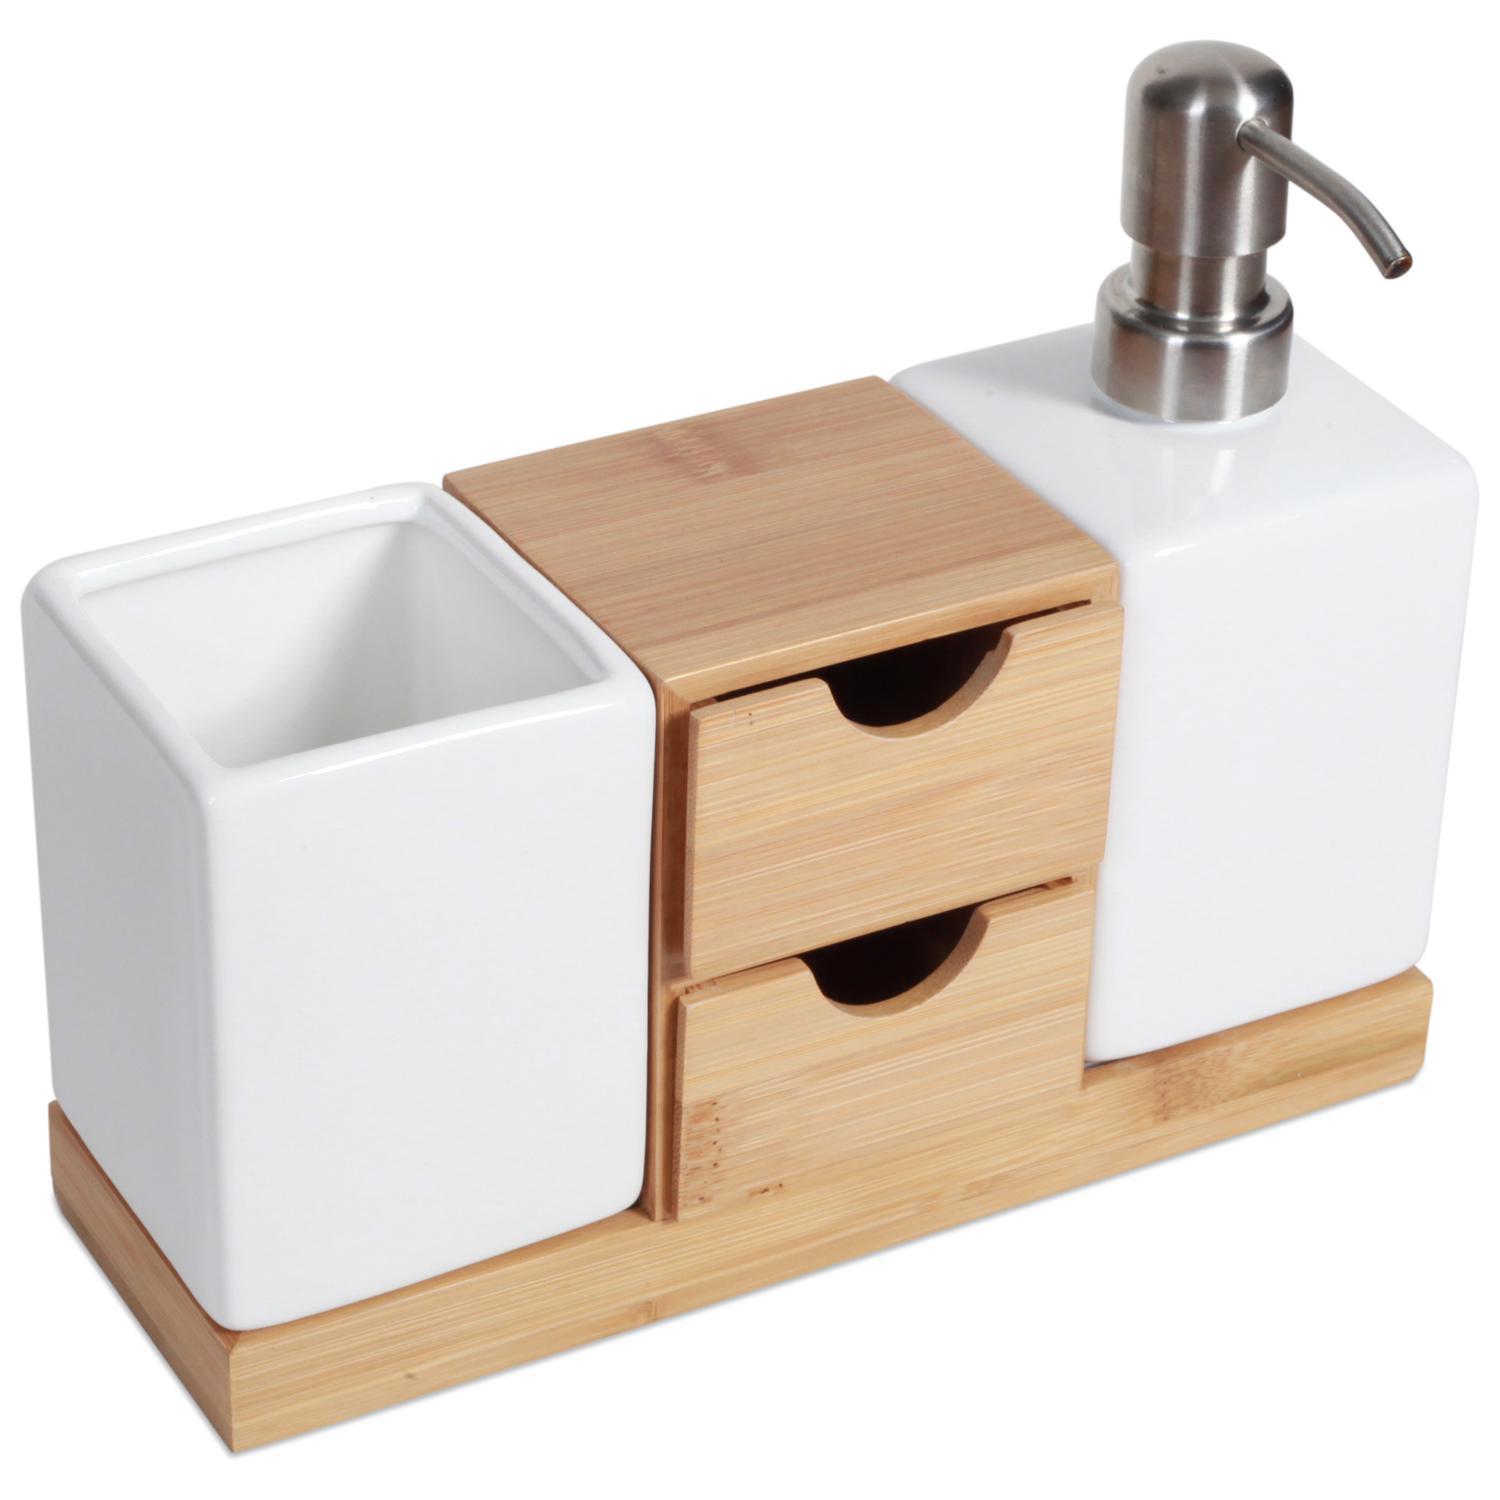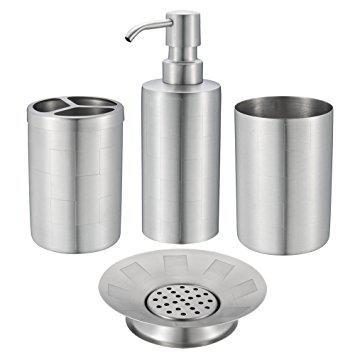The first image is the image on the left, the second image is the image on the right. Analyze the images presented: Is the assertion "None of the objects are brown in color" valid? Answer yes or no. No. The first image is the image on the left, the second image is the image on the right. Examine the images to the left and right. Is the description "An image shows a grouping of four coordinating vanity pieces, with a pump dispenser on the far left." accurate? Answer yes or no. No. 